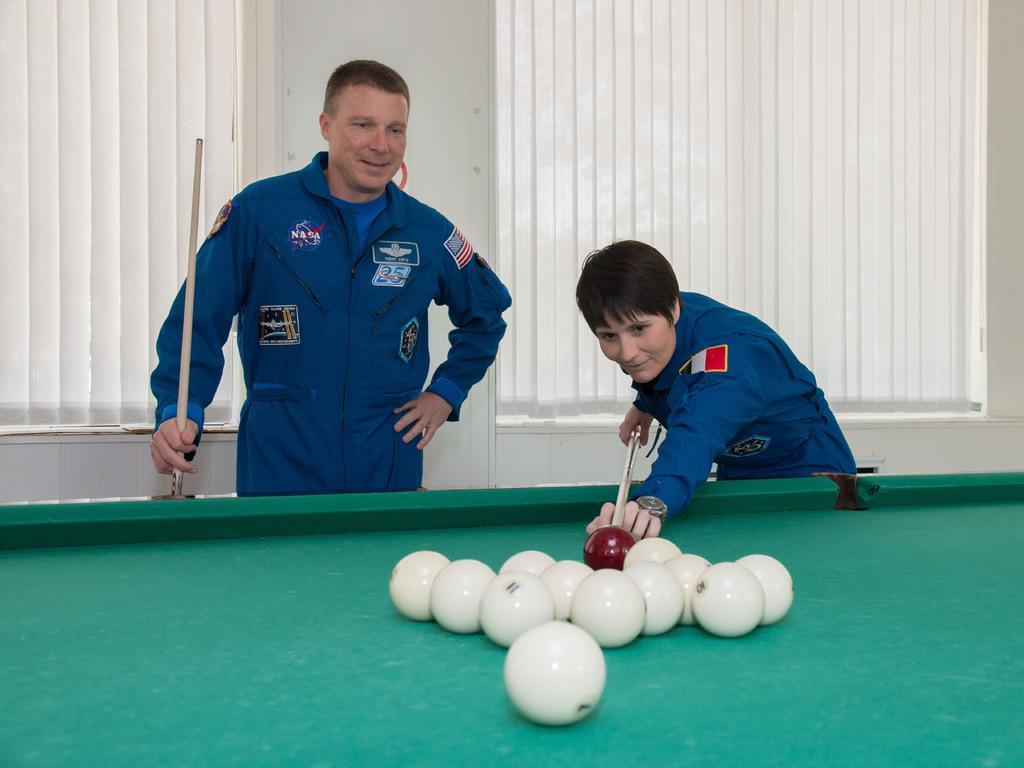In one or two sentences, can you explain what this image depicts? there is a man and woman in a uniform playing snookers on this snooker board. 